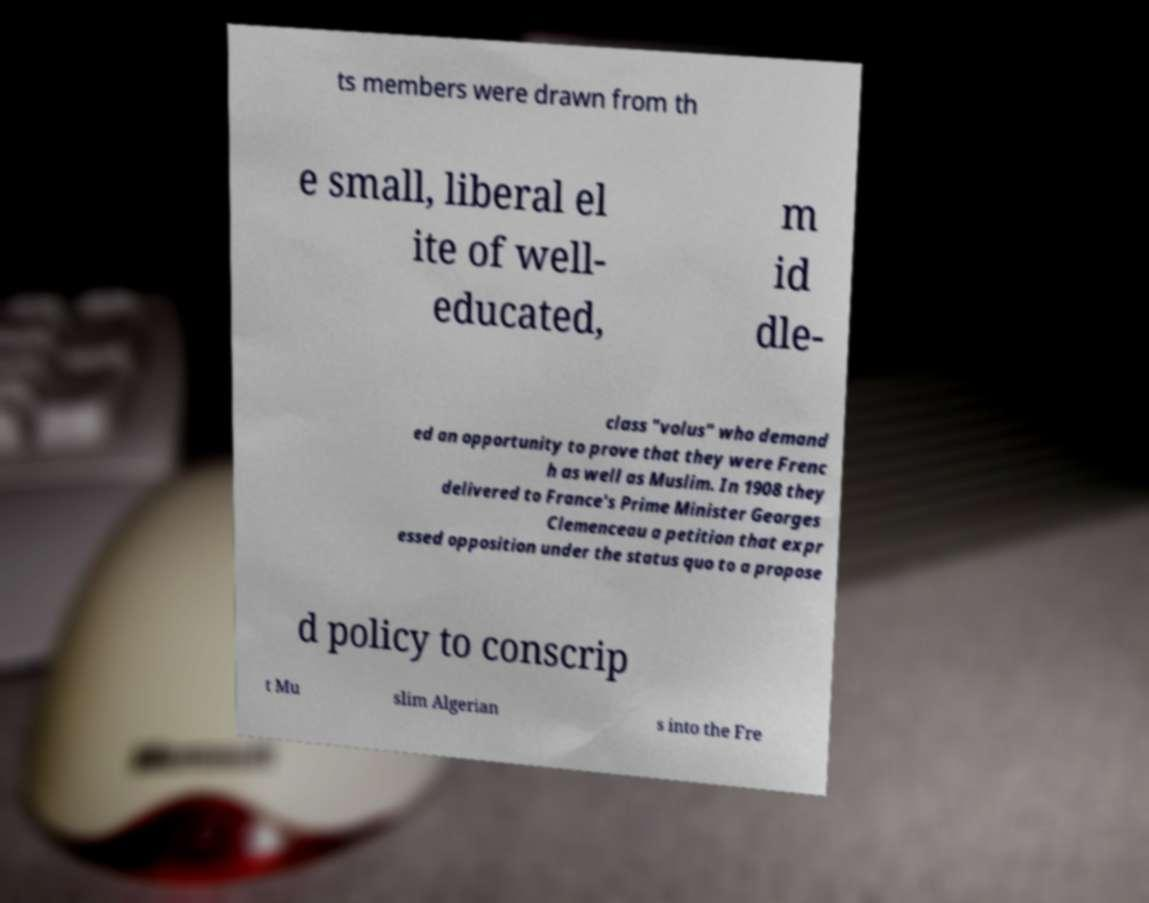For documentation purposes, I need the text within this image transcribed. Could you provide that? ts members were drawn from th e small, liberal el ite of well- educated, m id dle- class "volus" who demand ed an opportunity to prove that they were Frenc h as well as Muslim. In 1908 they delivered to France's Prime Minister Georges Clemenceau a petition that expr essed opposition under the status quo to a propose d policy to conscrip t Mu slim Algerian s into the Fre 